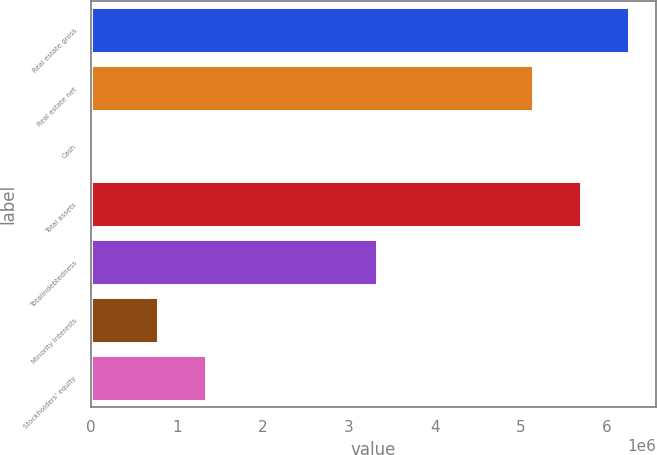<chart> <loc_0><loc_0><loc_500><loc_500><bar_chart><fcel>Real estate gross<fcel>Real estate net<fcel>Cash<fcel>Total assets<fcel>Totalindebtedness<fcel>Minority interests<fcel>Stockholders' equity<nl><fcel>6.25831e+06<fcel>5.13883e+06<fcel>12035<fcel>5.69857e+06<fcel>3.32158e+06<fcel>781962<fcel>1.3417e+06<nl></chart> 